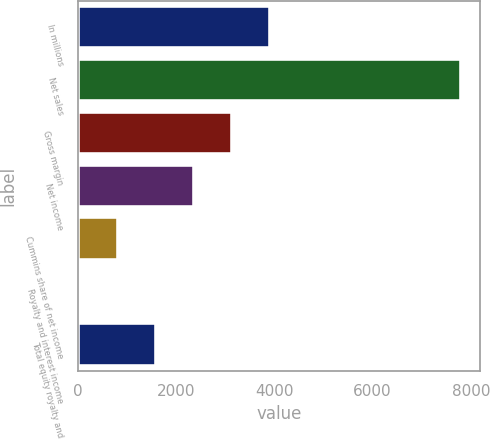Convert chart. <chart><loc_0><loc_0><loc_500><loc_500><bar_chart><fcel>In millions<fcel>Net sales<fcel>Gross margin<fcel>Net income<fcel>Cummins share of net income<fcel>Royalty and interest income<fcel>Total equity royalty and<nl><fcel>3917.5<fcel>7799<fcel>3141.2<fcel>2364.9<fcel>812.3<fcel>36<fcel>1588.6<nl></chart> 